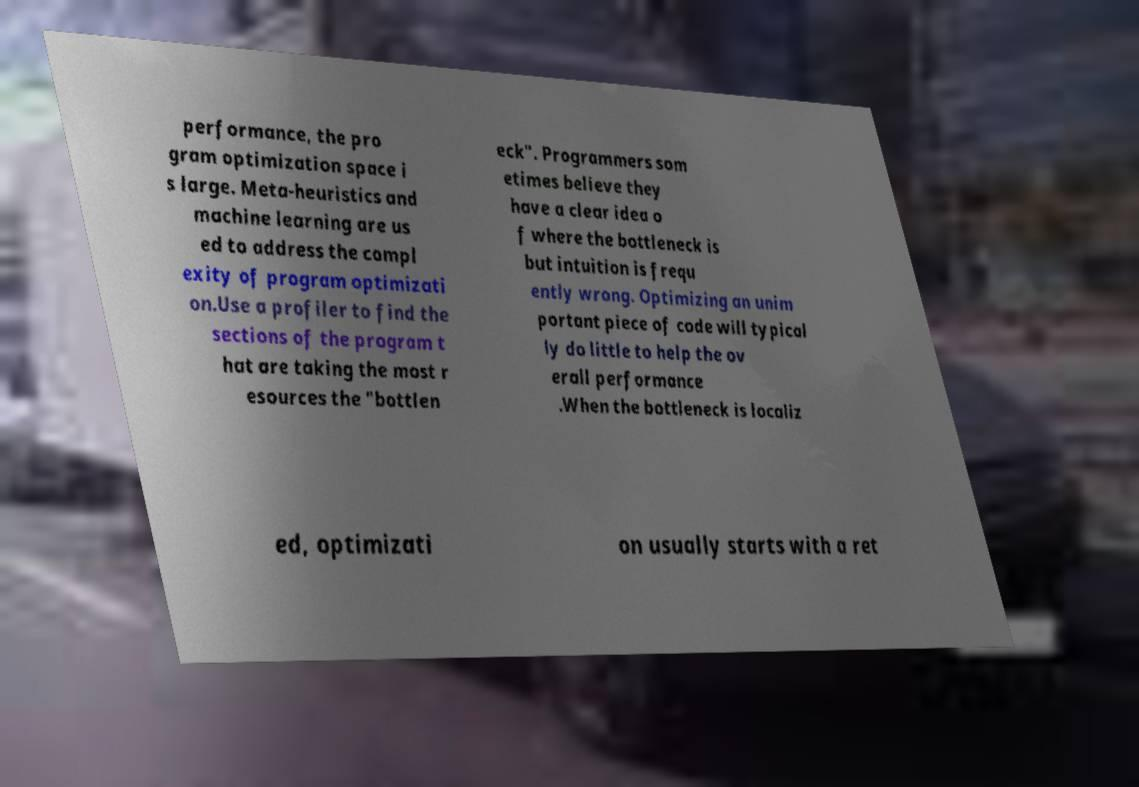What messages or text are displayed in this image? I need them in a readable, typed format. performance, the pro gram optimization space i s large. Meta-heuristics and machine learning are us ed to address the compl exity of program optimizati on.Use a profiler to find the sections of the program t hat are taking the most r esources the "bottlen eck". Programmers som etimes believe they have a clear idea o f where the bottleneck is but intuition is frequ ently wrong. Optimizing an unim portant piece of code will typical ly do little to help the ov erall performance .When the bottleneck is localiz ed, optimizati on usually starts with a ret 